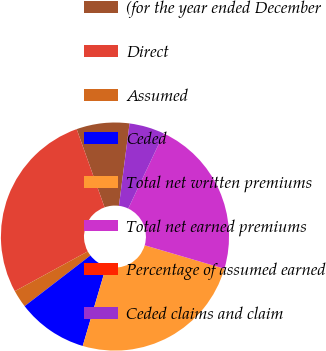<chart> <loc_0><loc_0><loc_500><loc_500><pie_chart><fcel>(for the year ended December<fcel>Direct<fcel>Assumed<fcel>Ceded<fcel>Total net written premiums<fcel>Total net earned premiums<fcel>Percentage of assumed earned<fcel>Ceded claims and claim<nl><fcel>7.49%<fcel>27.5%<fcel>2.5%<fcel>9.99%<fcel>25.01%<fcel>22.51%<fcel>0.0%<fcel>5.0%<nl></chart> 